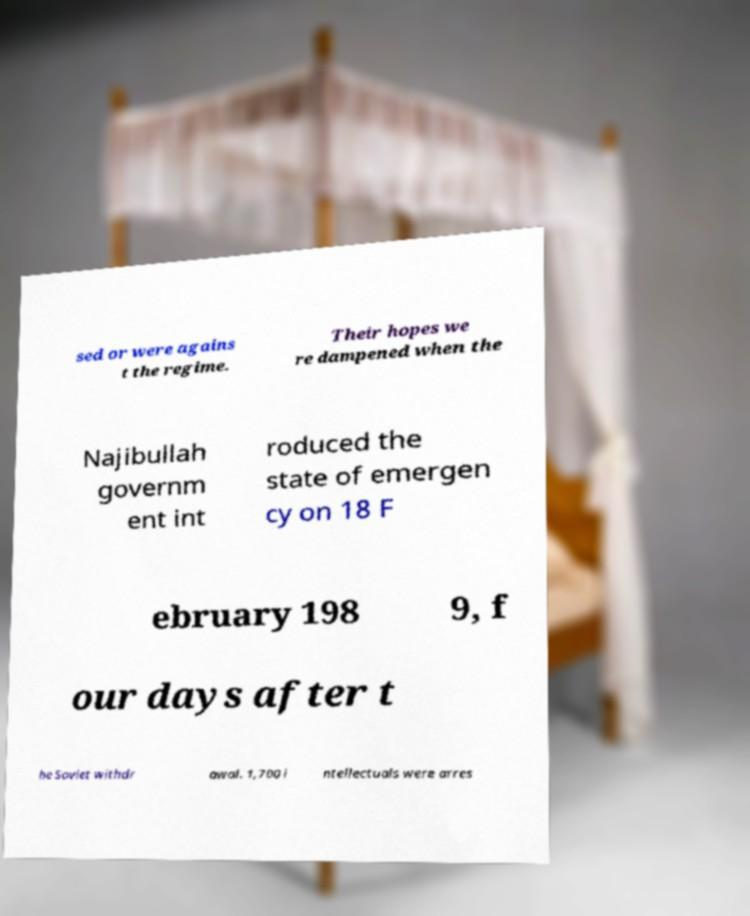Can you accurately transcribe the text from the provided image for me? sed or were agains t the regime. Their hopes we re dampened when the Najibullah governm ent int roduced the state of emergen cy on 18 F ebruary 198 9, f our days after t he Soviet withdr awal. 1,700 i ntellectuals were arres 